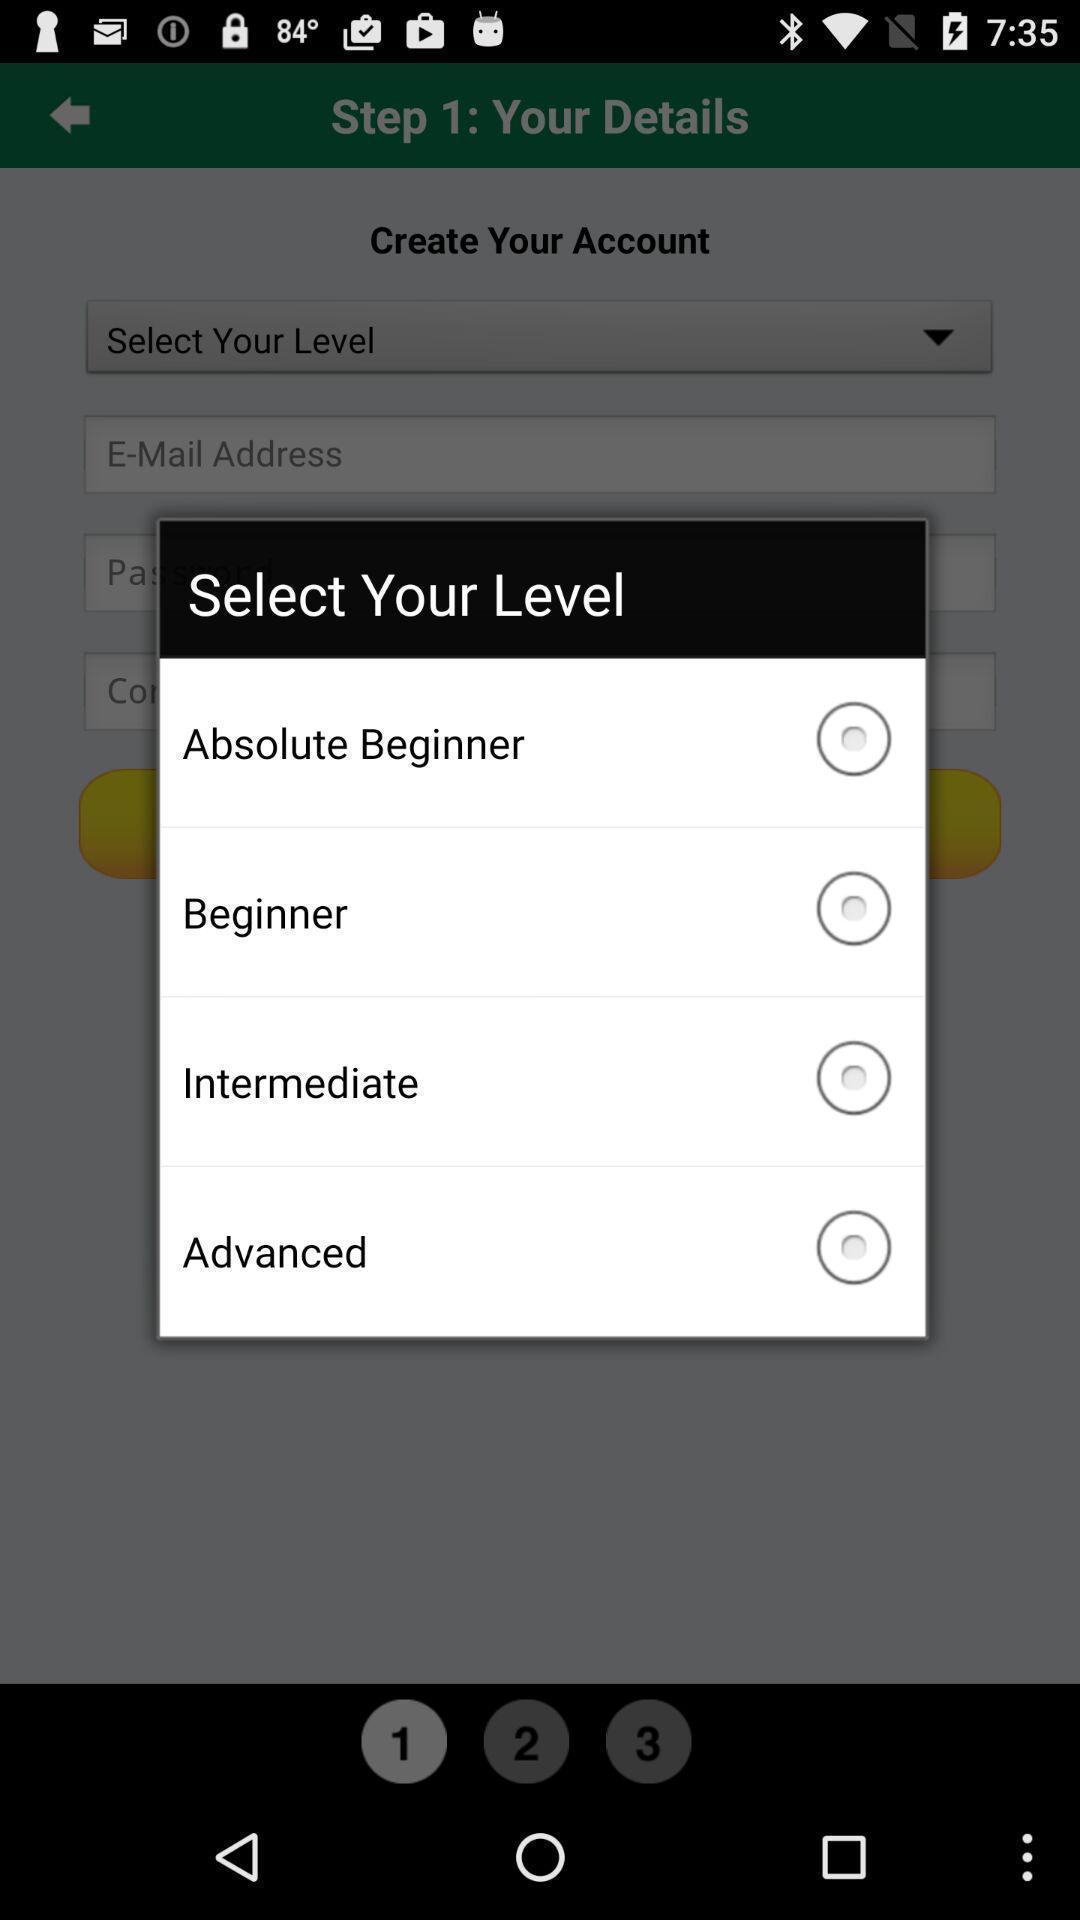Give me a narrative description of this picture. Pop-up showing to select level. 